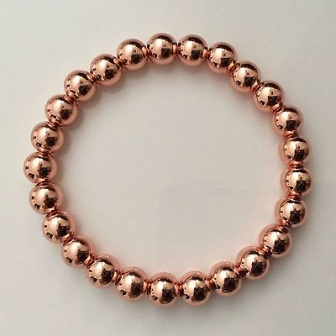What do you think is going on in this snapshot? This image showcases an elegant bracelet composed of 18 uniformly-sized, lustrous copper-colored beads. Arranged meticulously in a perfect circle, the bracelet is prominently displayed against a pristine white surface, creating a striking contrast. The arrangement emphasizes the simplicity and beauty of the piece, inviting viewers to appreciate the craftsmanship and design. There are no other objects or distractions in the frame, allowing the bracelet to be the sole focus of the snapshot. 